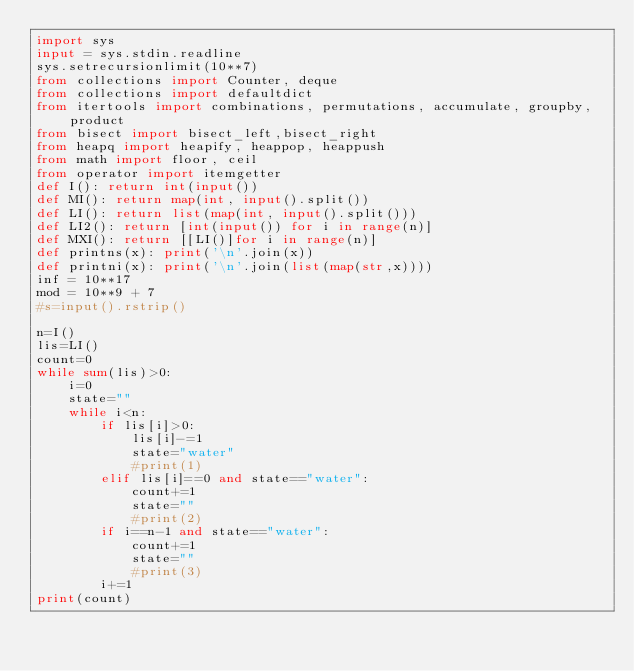<code> <loc_0><loc_0><loc_500><loc_500><_Python_>import sys
input = sys.stdin.readline
sys.setrecursionlimit(10**7)
from collections import Counter, deque
from collections import defaultdict
from itertools import combinations, permutations, accumulate, groupby, product
from bisect import bisect_left,bisect_right
from heapq import heapify, heappop, heappush
from math import floor, ceil
from operator import itemgetter
def I(): return int(input())
def MI(): return map(int, input().split())
def LI(): return list(map(int, input().split()))
def LI2(): return [int(input()) for i in range(n)]
def MXI(): return [[LI()]for i in range(n)]
def printns(x): print('\n'.join(x))
def printni(x): print('\n'.join(list(map(str,x))))
inf = 10**17
mod = 10**9 + 7
#s=input().rstrip()

n=I()
lis=LI()
count=0
while sum(lis)>0:
    i=0
    state=""
    while i<n:
        if lis[i]>0:
            lis[i]-=1
            state="water"
            #print(1)
        elif lis[i]==0 and state=="water":
            count+=1
            state=""
            #print(2)
        if i==n-1 and state=="water":
            count+=1
            state=""
            #print(3)
        i+=1
print(count)</code> 